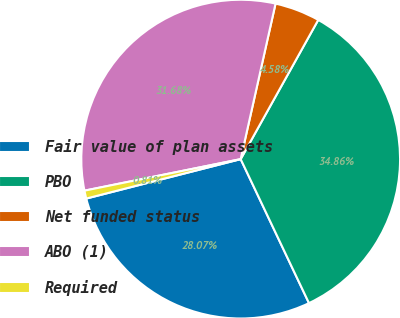Convert chart. <chart><loc_0><loc_0><loc_500><loc_500><pie_chart><fcel>Fair value of plan assets<fcel>PBO<fcel>Net funded status<fcel>ABO (1)<fcel>Required<nl><fcel>28.07%<fcel>34.86%<fcel>4.58%<fcel>31.68%<fcel>0.81%<nl></chart> 